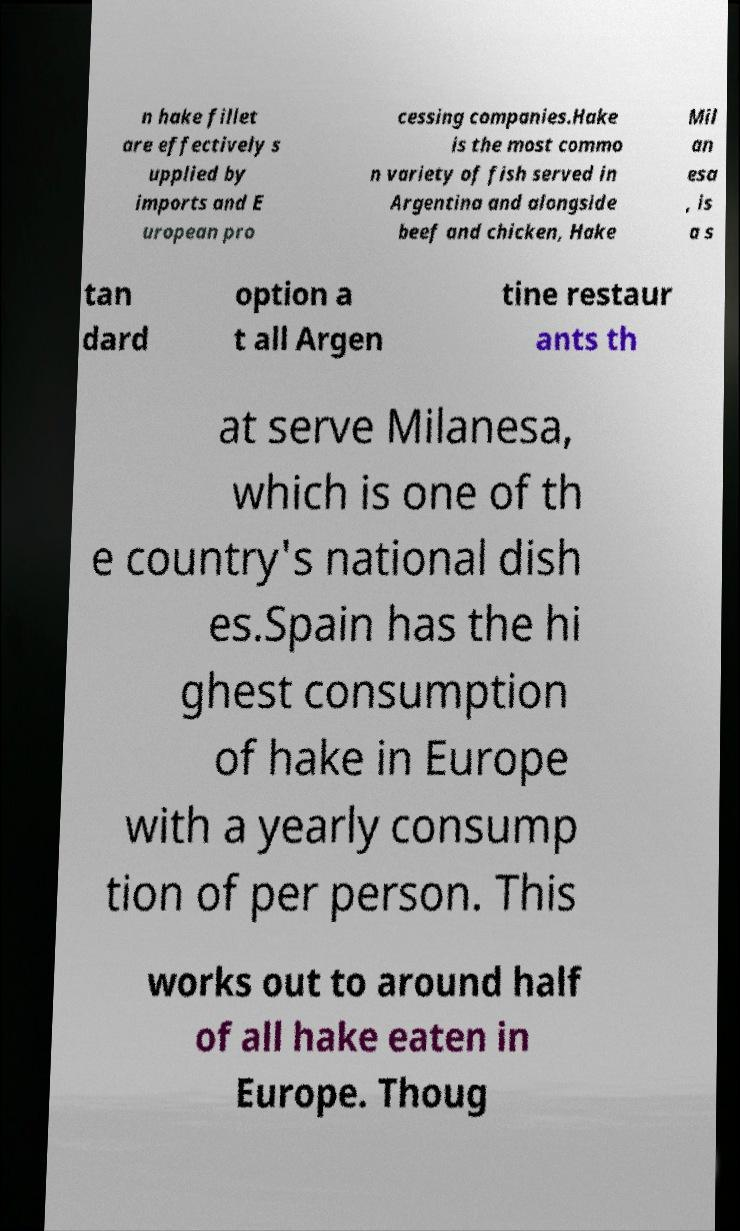Please identify and transcribe the text found in this image. n hake fillet are effectively s upplied by imports and E uropean pro cessing companies.Hake is the most commo n variety of fish served in Argentina and alongside beef and chicken, Hake Mil an esa , is a s tan dard option a t all Argen tine restaur ants th at serve Milanesa, which is one of th e country's national dish es.Spain has the hi ghest consumption of hake in Europe with a yearly consump tion of per person. This works out to around half of all hake eaten in Europe. Thoug 